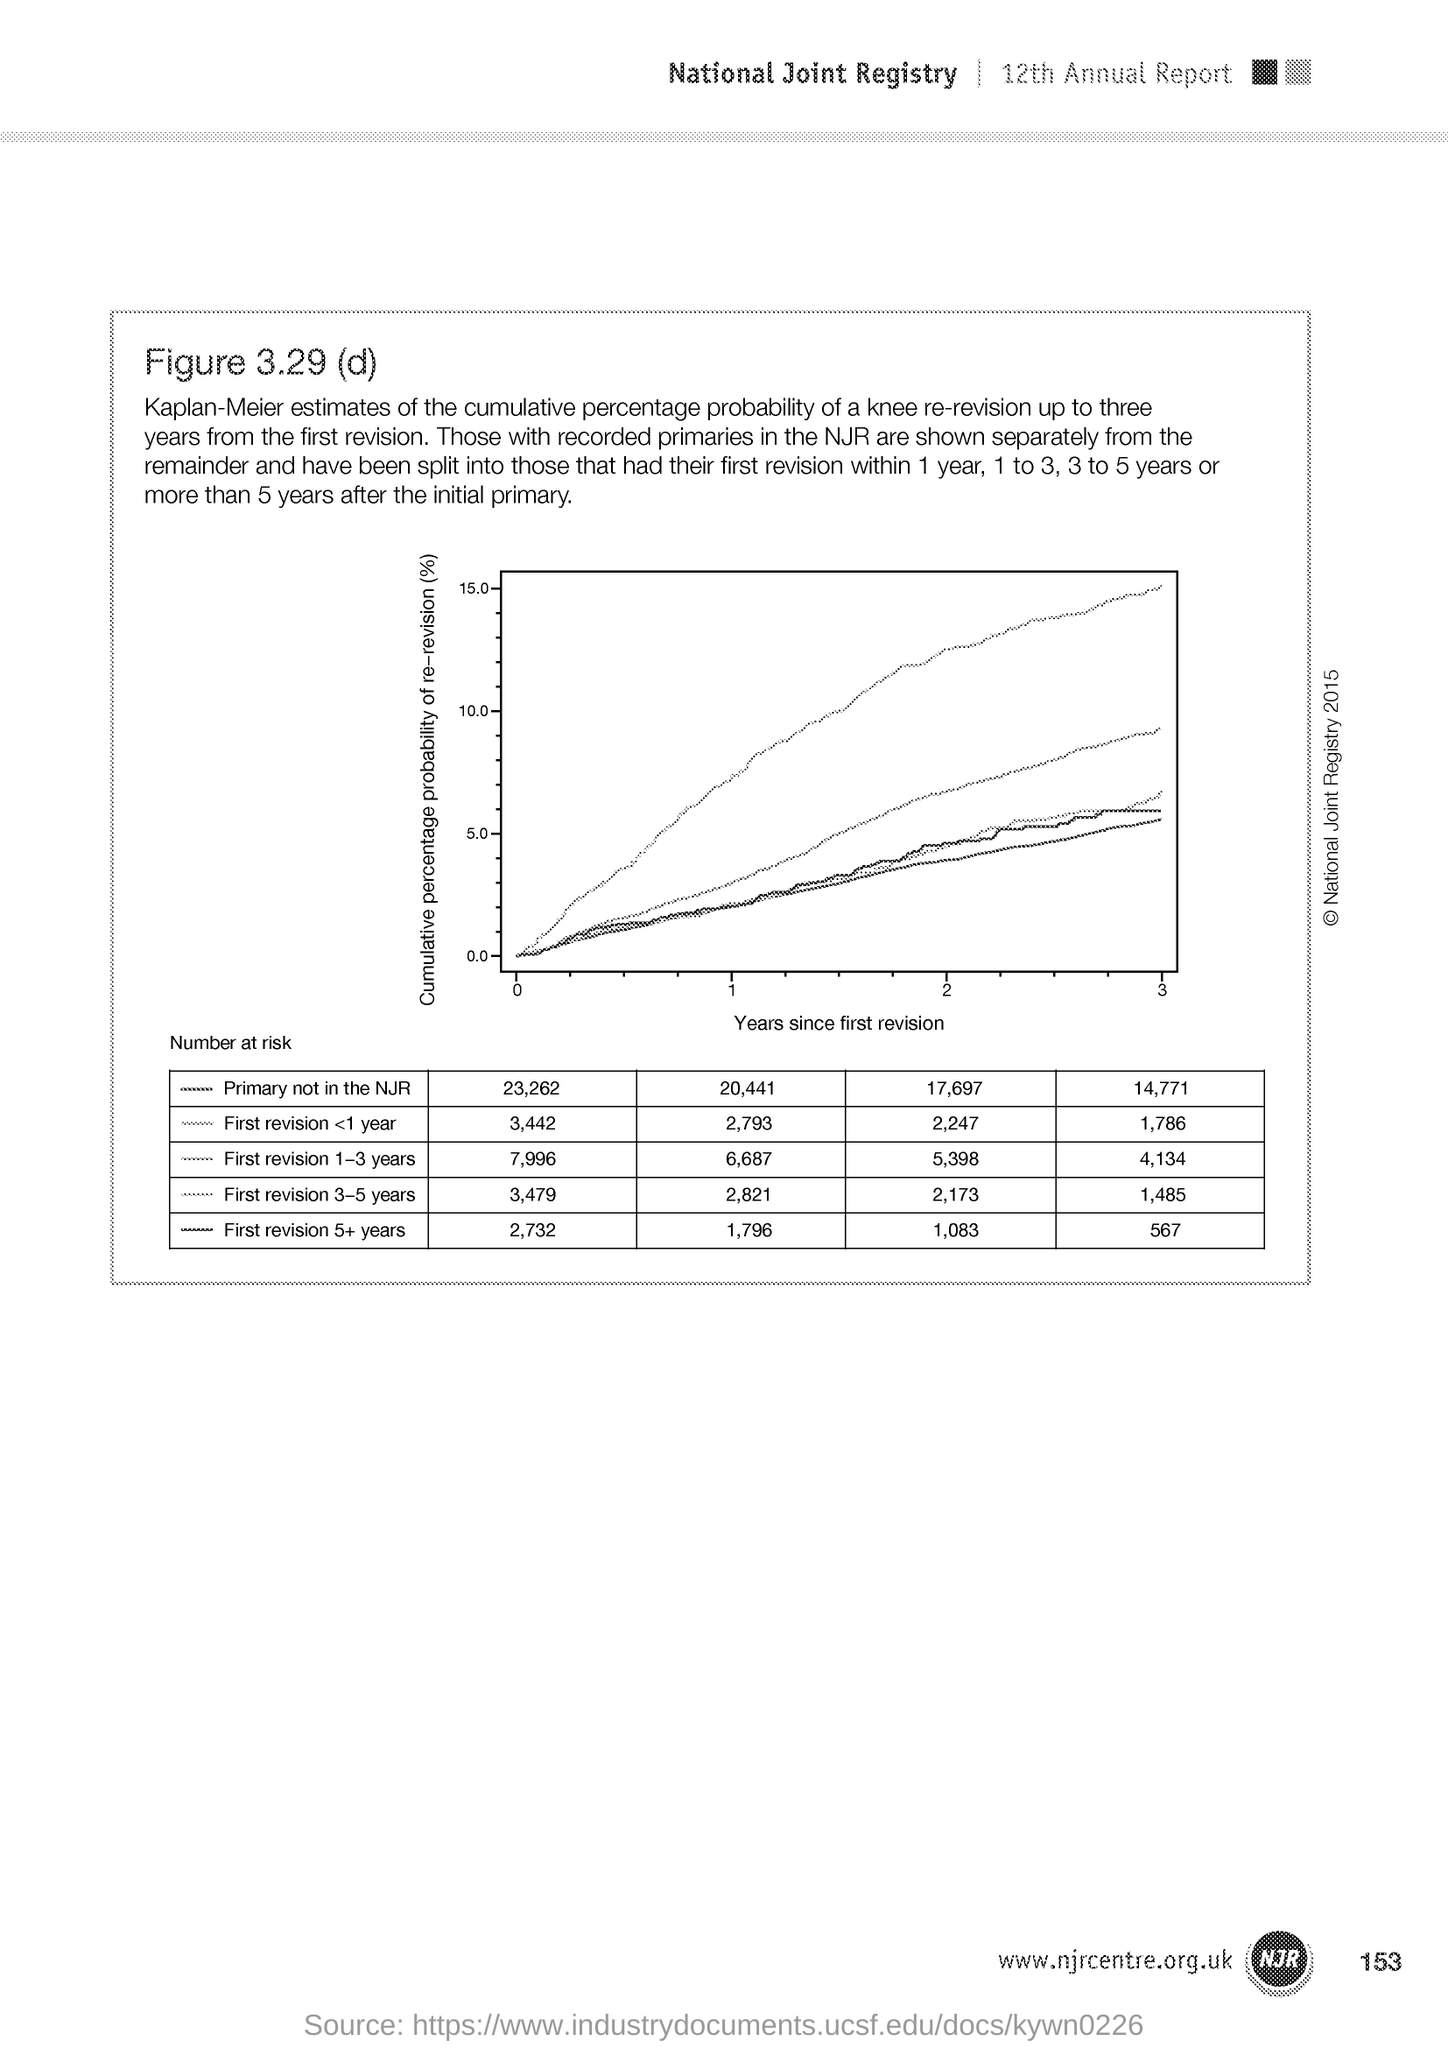Point out several critical features in this image. The number at the bottom right side of the page is 153. 